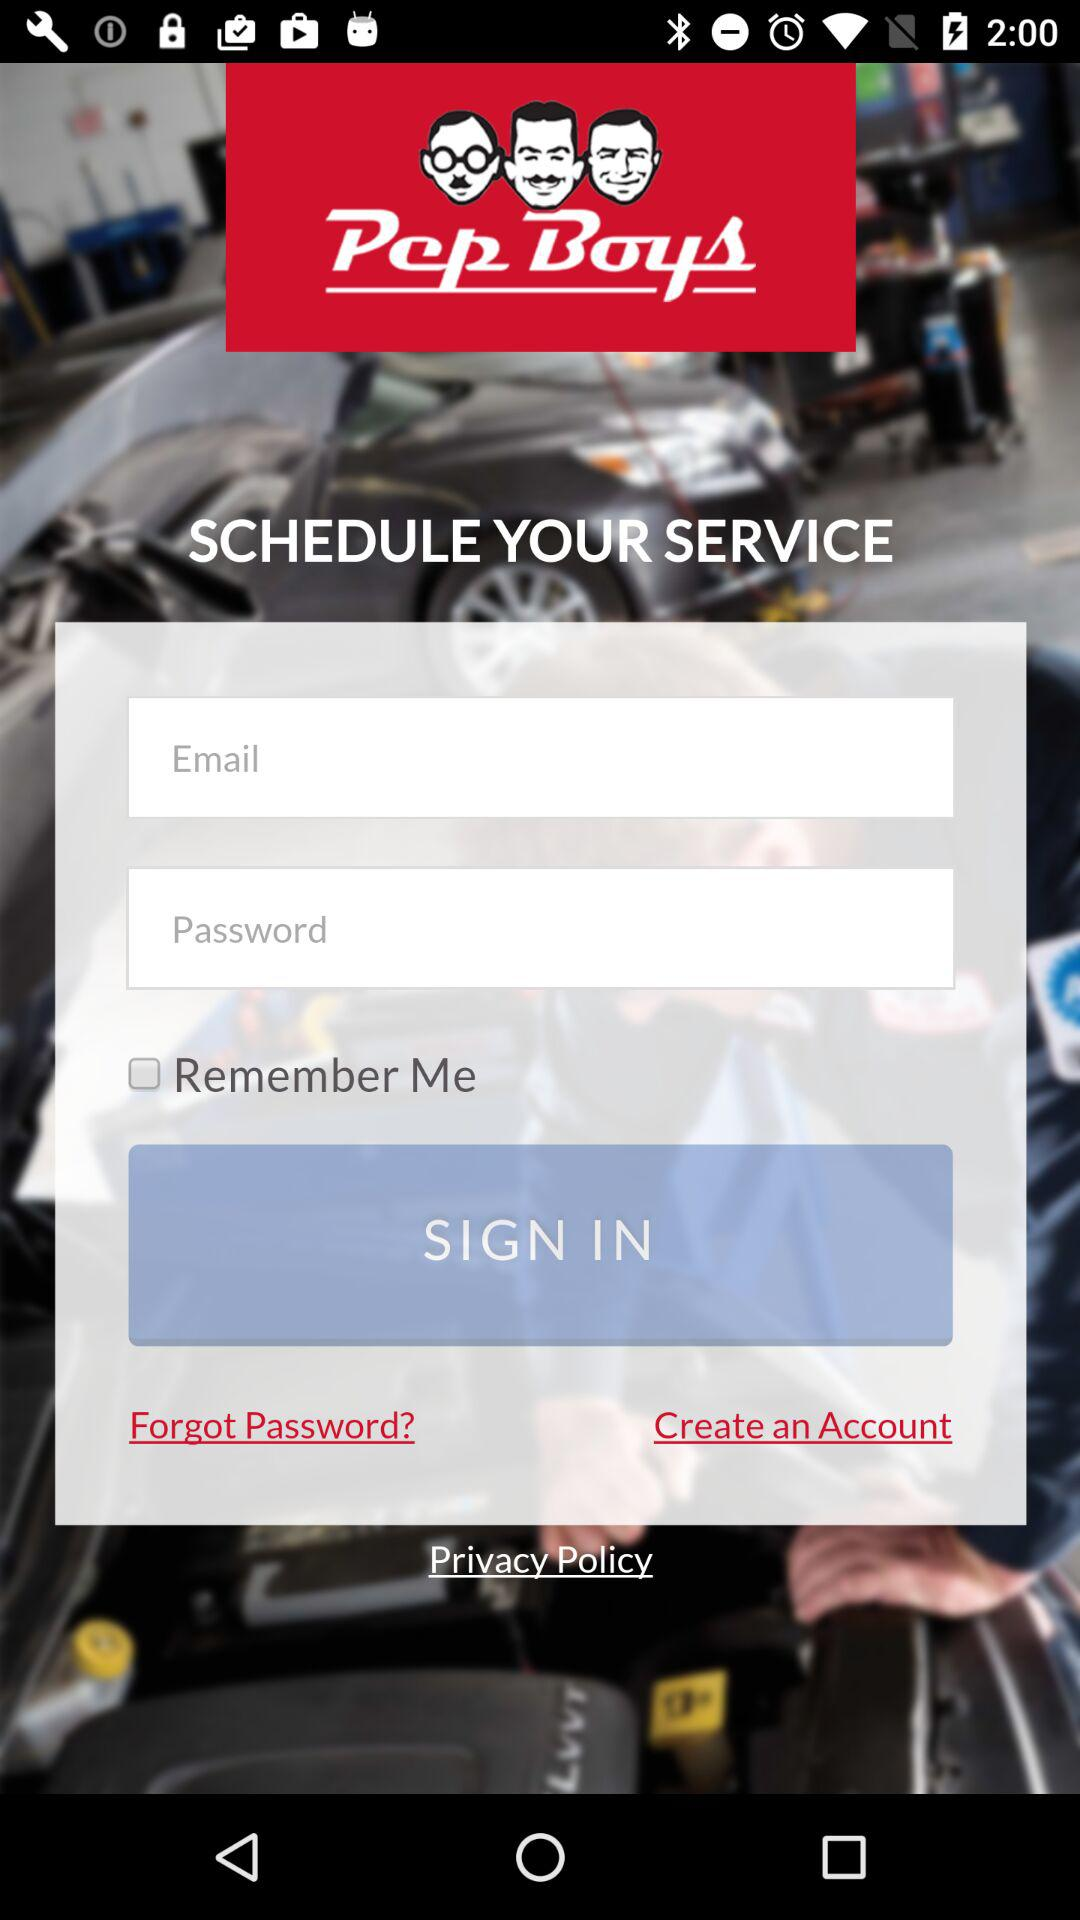What is the application name? The application name is "Pep Boys". 